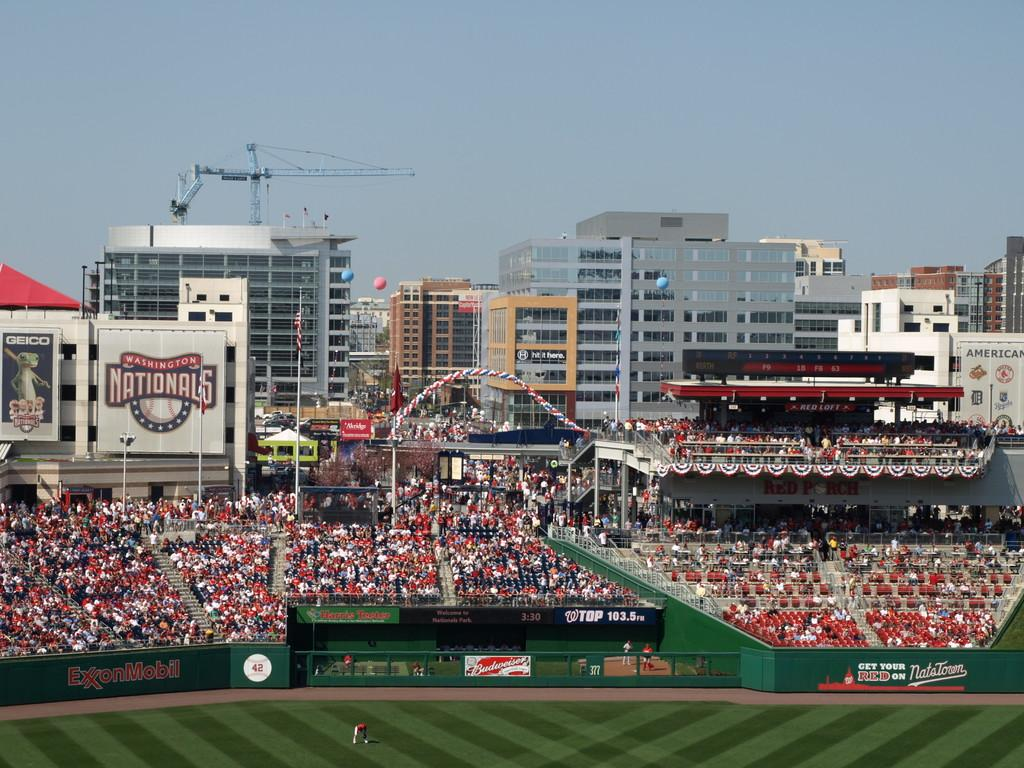Provide a one-sentence caption for the provided image. Baseball stadium full of fans from a distance, the home team is the nationals. 